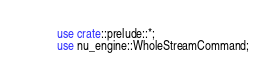Convert code to text. <code><loc_0><loc_0><loc_500><loc_500><_Rust_>use crate::prelude::*;
use nu_engine::WholeStreamCommand;</code> 